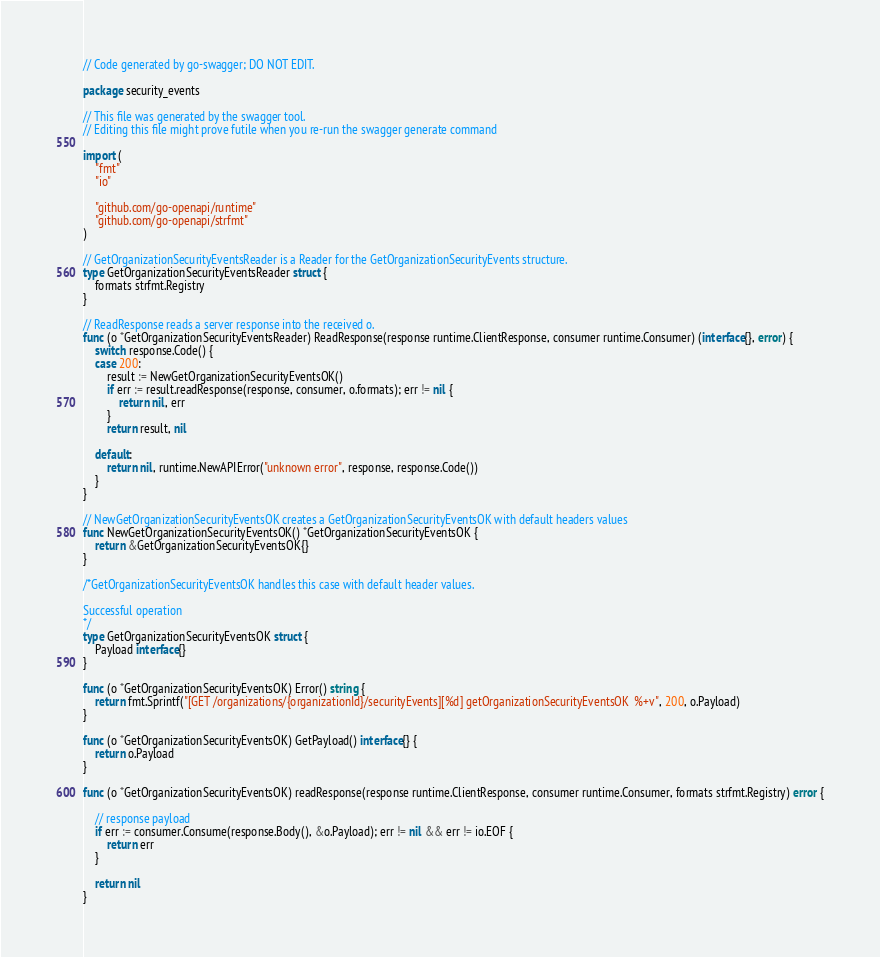<code> <loc_0><loc_0><loc_500><loc_500><_Go_>// Code generated by go-swagger; DO NOT EDIT.

package security_events

// This file was generated by the swagger tool.
// Editing this file might prove futile when you re-run the swagger generate command

import (
	"fmt"
	"io"

	"github.com/go-openapi/runtime"
	"github.com/go-openapi/strfmt"
)

// GetOrganizationSecurityEventsReader is a Reader for the GetOrganizationSecurityEvents structure.
type GetOrganizationSecurityEventsReader struct {
	formats strfmt.Registry
}

// ReadResponse reads a server response into the received o.
func (o *GetOrganizationSecurityEventsReader) ReadResponse(response runtime.ClientResponse, consumer runtime.Consumer) (interface{}, error) {
	switch response.Code() {
	case 200:
		result := NewGetOrganizationSecurityEventsOK()
		if err := result.readResponse(response, consumer, o.formats); err != nil {
			return nil, err
		}
		return result, nil

	default:
		return nil, runtime.NewAPIError("unknown error", response, response.Code())
	}
}

// NewGetOrganizationSecurityEventsOK creates a GetOrganizationSecurityEventsOK with default headers values
func NewGetOrganizationSecurityEventsOK() *GetOrganizationSecurityEventsOK {
	return &GetOrganizationSecurityEventsOK{}
}

/*GetOrganizationSecurityEventsOK handles this case with default header values.

Successful operation
*/
type GetOrganizationSecurityEventsOK struct {
	Payload interface{}
}

func (o *GetOrganizationSecurityEventsOK) Error() string {
	return fmt.Sprintf("[GET /organizations/{organizationId}/securityEvents][%d] getOrganizationSecurityEventsOK  %+v", 200, o.Payload)
}

func (o *GetOrganizationSecurityEventsOK) GetPayload() interface{} {
	return o.Payload
}

func (o *GetOrganizationSecurityEventsOK) readResponse(response runtime.ClientResponse, consumer runtime.Consumer, formats strfmt.Registry) error {

	// response payload
	if err := consumer.Consume(response.Body(), &o.Payload); err != nil && err != io.EOF {
		return err
	}

	return nil
}
</code> 